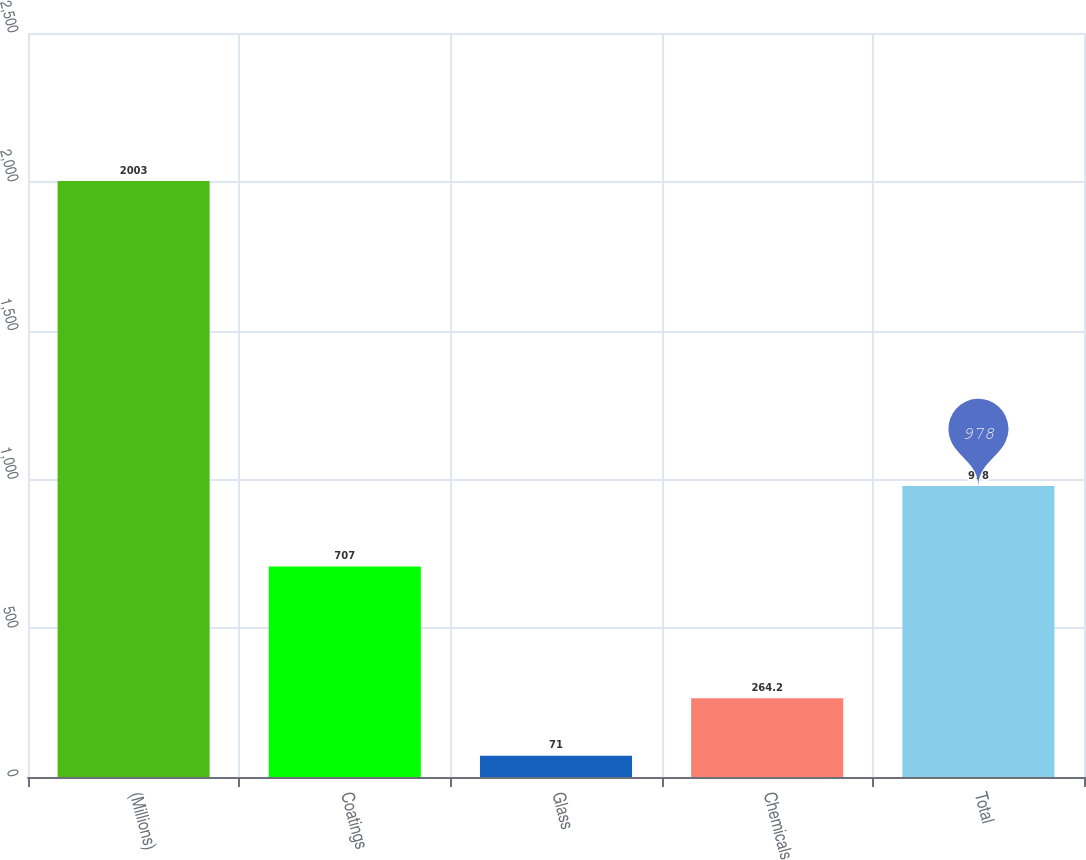<chart> <loc_0><loc_0><loc_500><loc_500><bar_chart><fcel>(Millions)<fcel>Coatings<fcel>Glass<fcel>Chemicals<fcel>Total<nl><fcel>2003<fcel>707<fcel>71<fcel>264.2<fcel>978<nl></chart> 